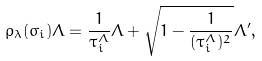<formula> <loc_0><loc_0><loc_500><loc_500>\rho _ { \lambda } ( \sigma _ { i } ) \Lambda = \frac { 1 } { \tau _ { i } ^ { \Lambda } } \Lambda + \sqrt { 1 - \frac { 1 } { ( \tau _ { i } ^ { \Lambda } ) ^ { 2 } } } \Lambda ^ { \prime } ,</formula> 